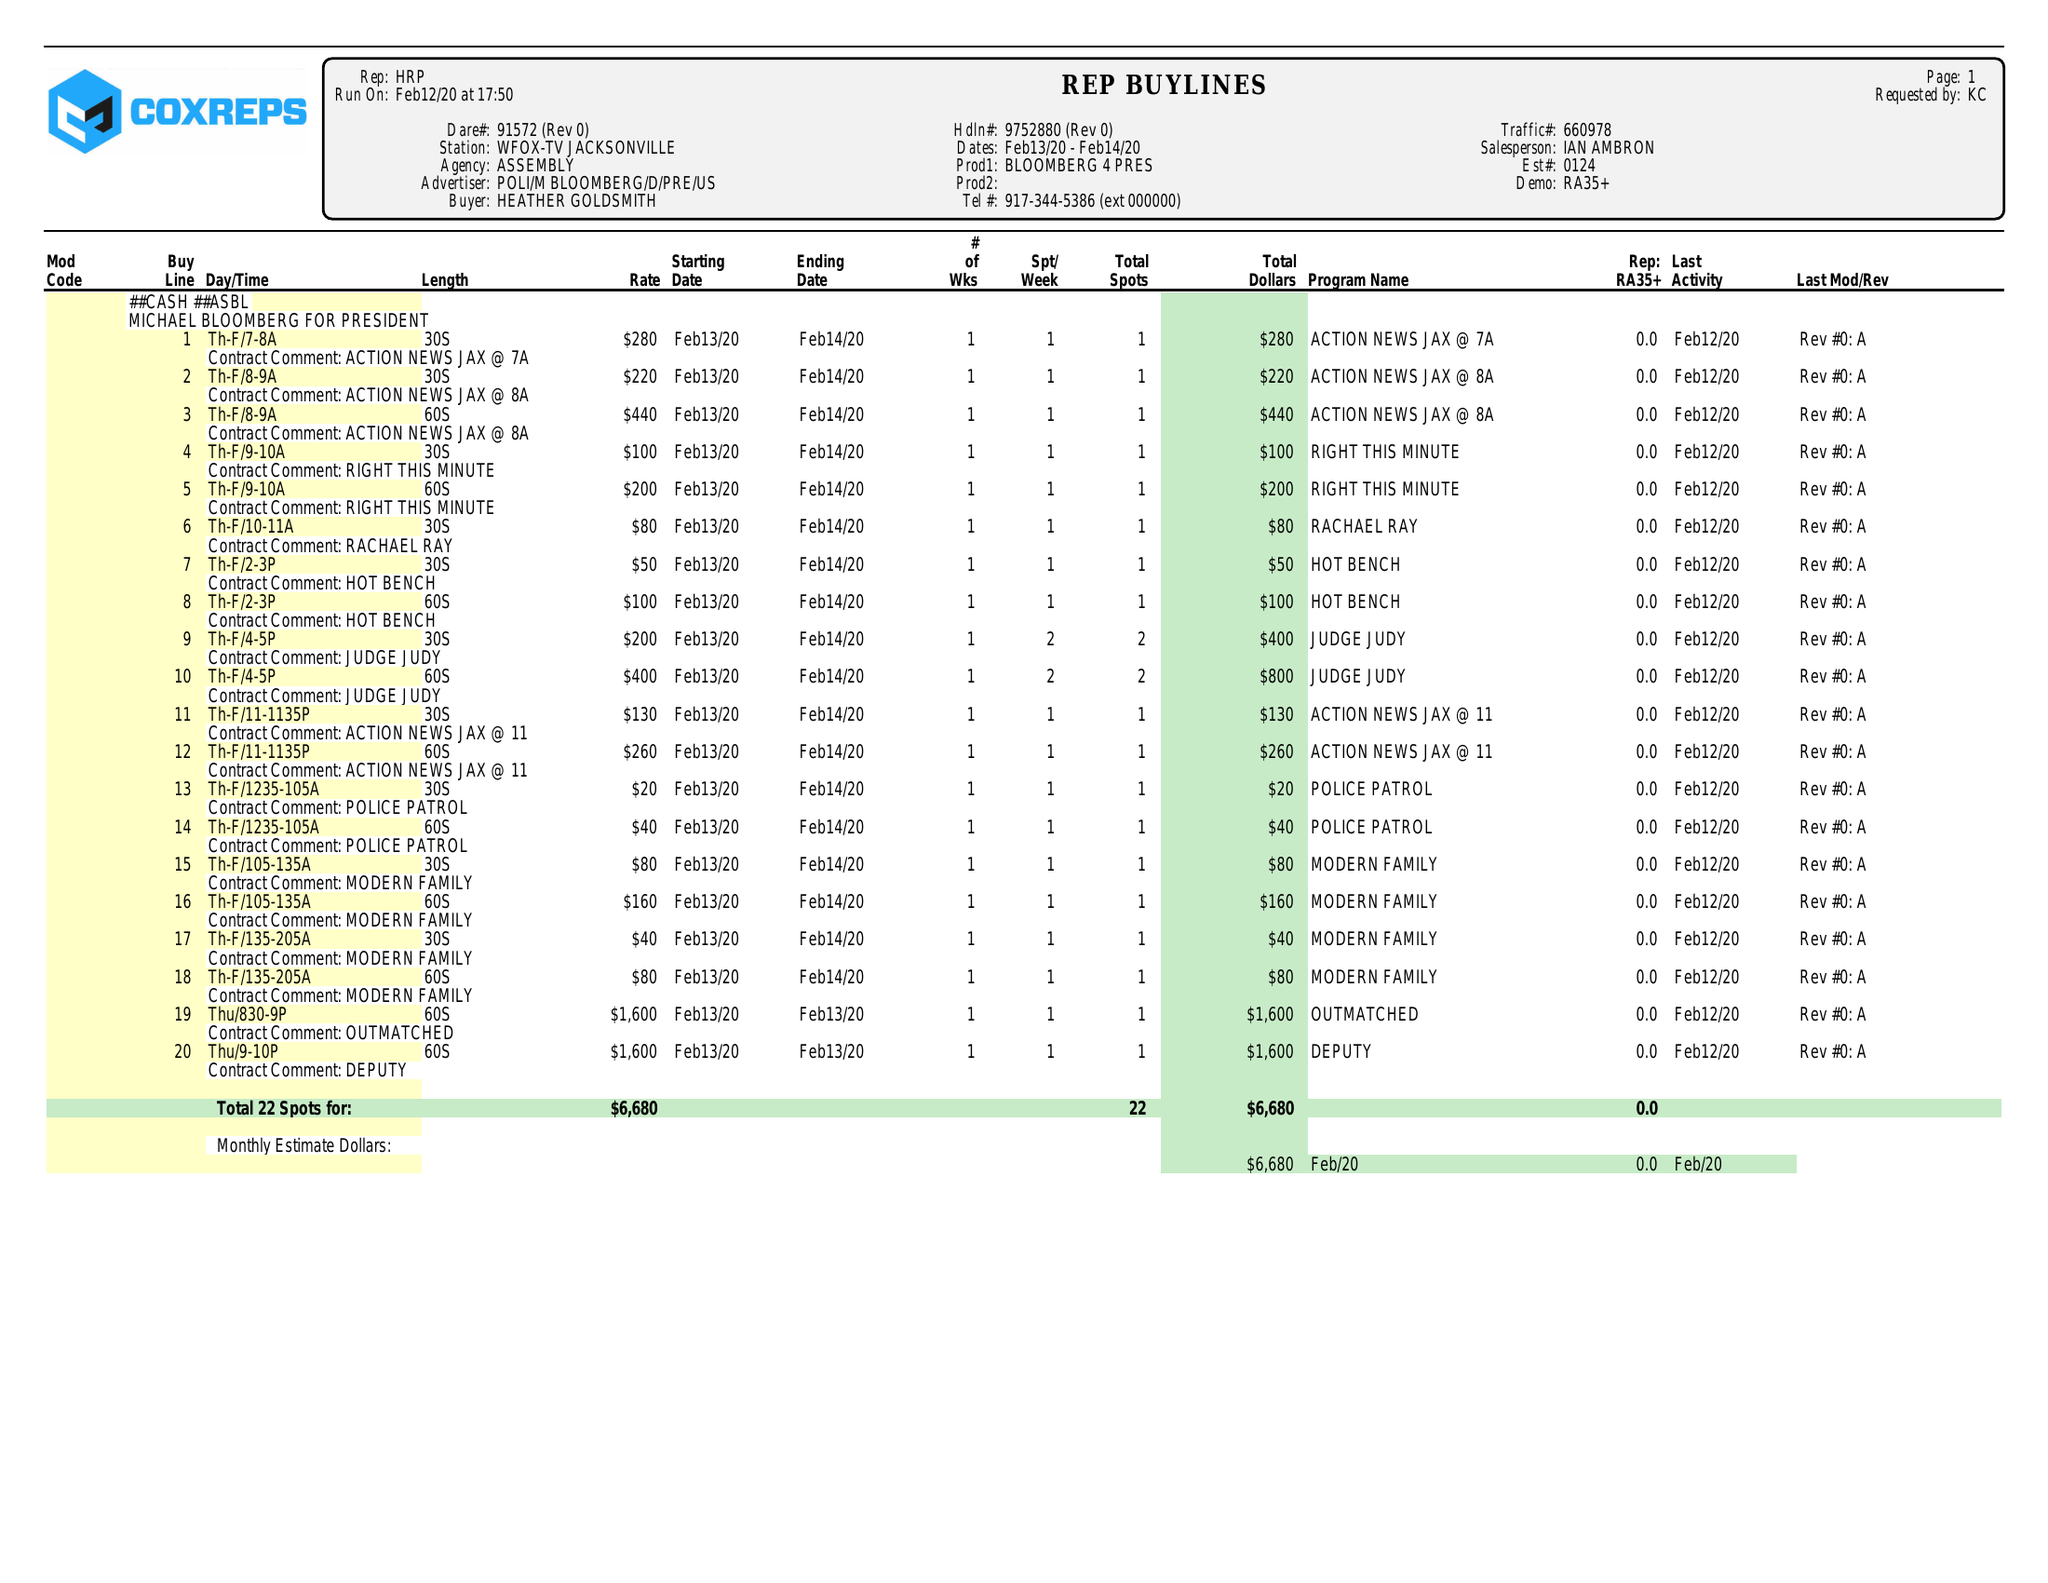What is the value for the flight_from?
Answer the question using a single word or phrase. 02/13/20 